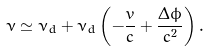<formula> <loc_0><loc_0><loc_500><loc_500>\nu \simeq \nu _ { d } + \nu _ { d } \left ( - \frac { v } { c } + \frac { \Delta \phi } { c ^ { 2 } } \right ) .</formula> 